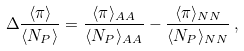Convert formula to latex. <formula><loc_0><loc_0><loc_500><loc_500>\Delta \frac { \langle \pi \rangle } { \langle N _ { P } \rangle } = \frac { \langle \pi \rangle _ { A A } } { \langle N _ { P } \rangle _ { A A } } - \frac { \langle \pi \rangle _ { N N } } { \langle N _ { P } \rangle _ { N N } } \, ,</formula> 